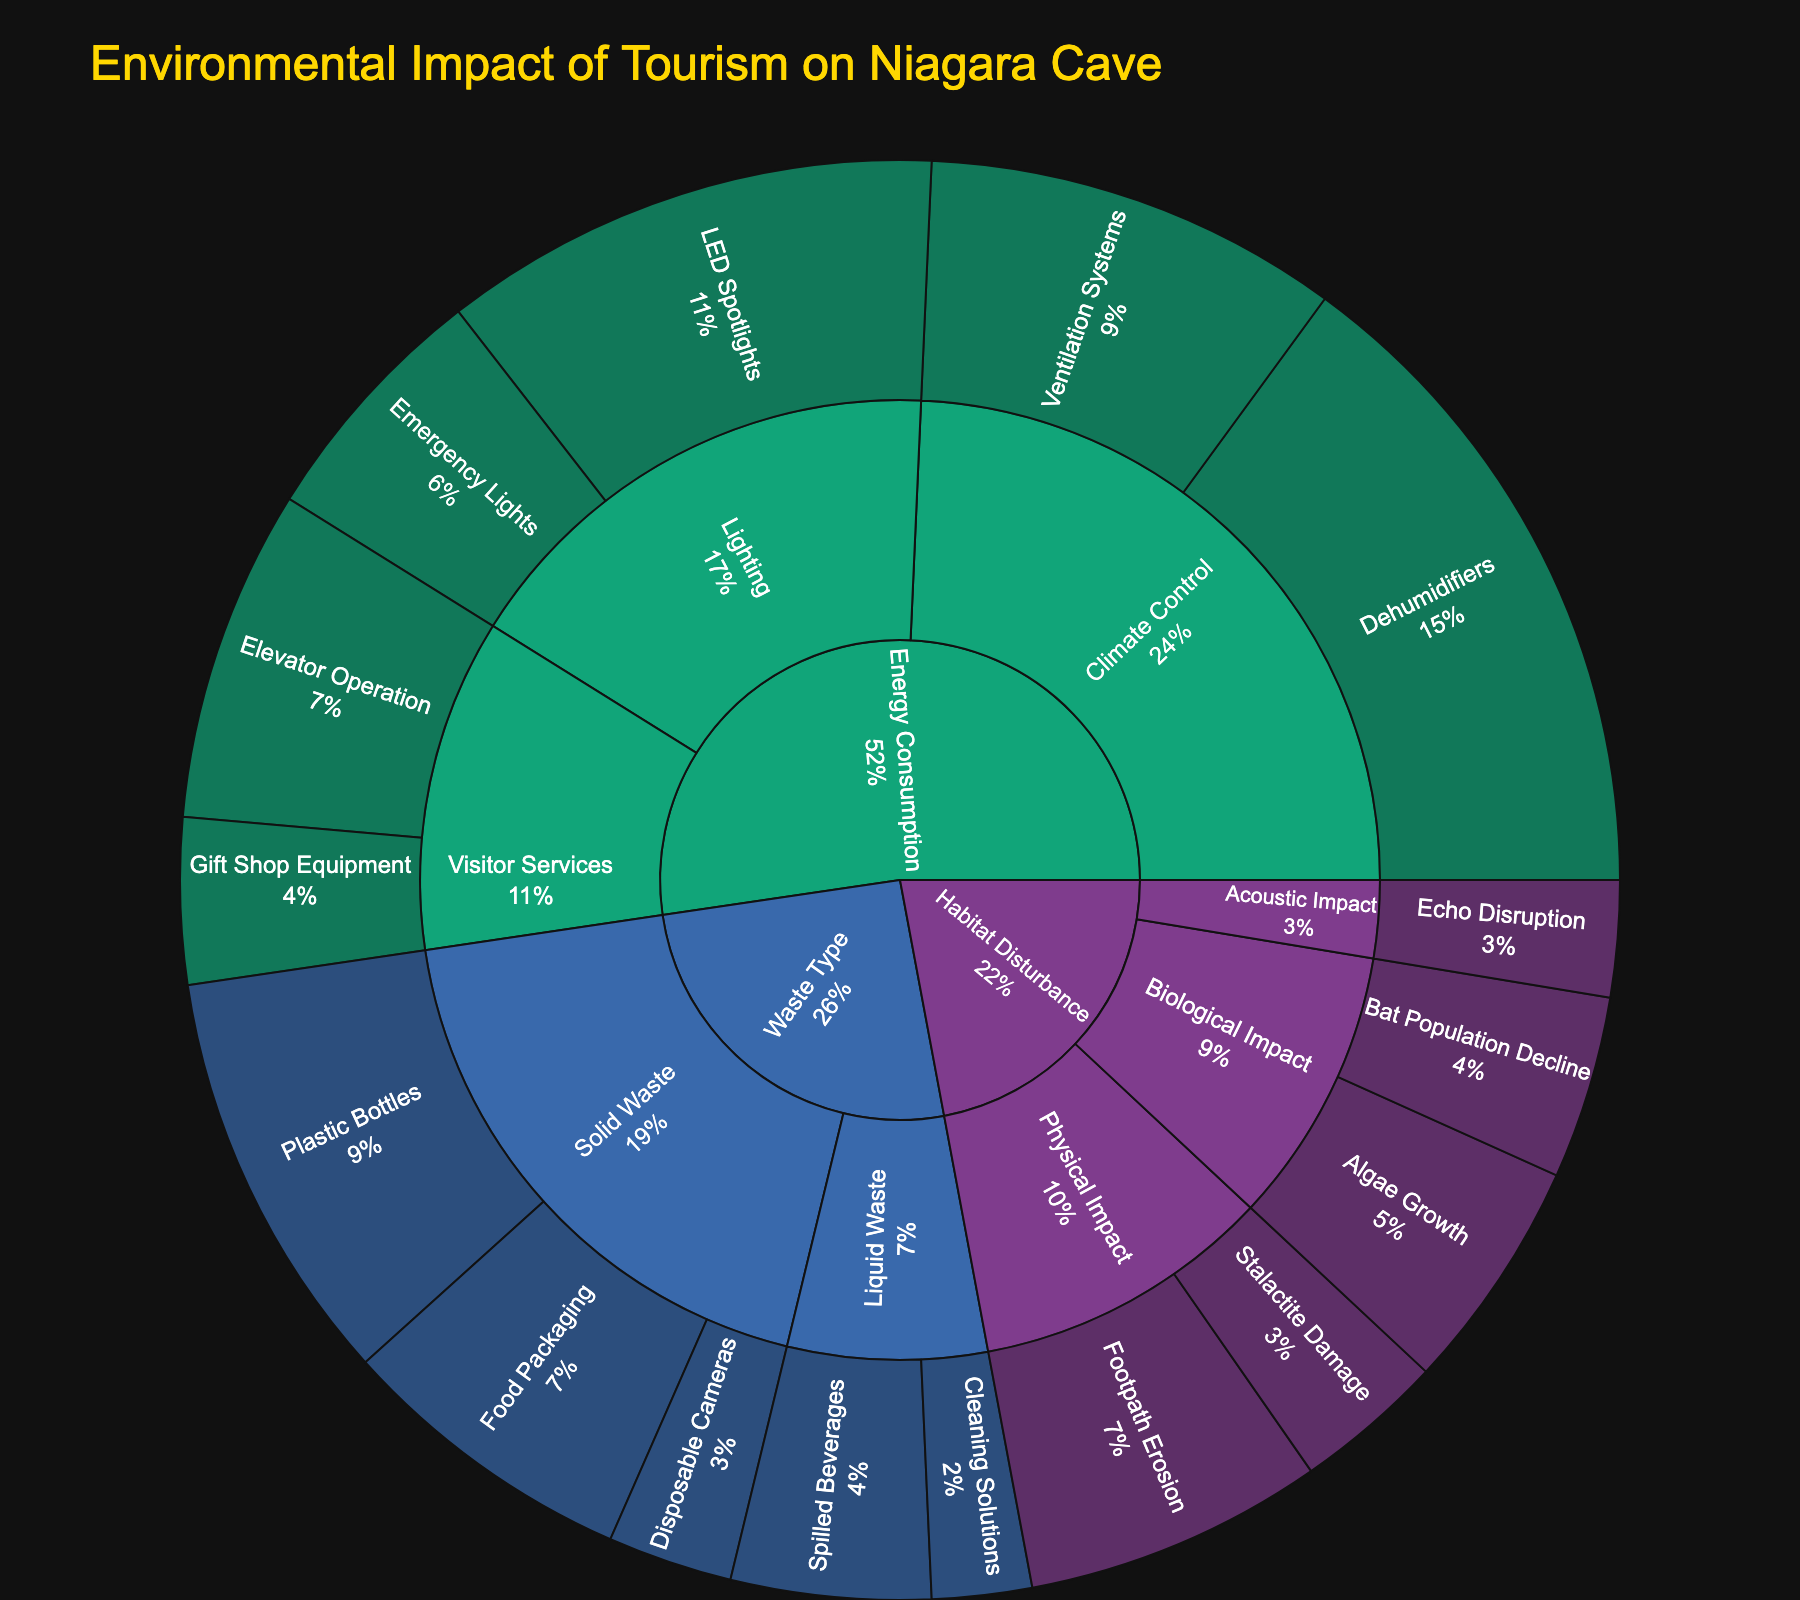What's the title of the figure? The title of the figure is located at the top center of the plot and provides a summary of what the plot represents.
Answer: Environmental Impact of Tourism on Niagara Cave Which waste type has a higher total impact, Solid or Liquid? Add the values of all items under Solid Waste and compare with the sum of values under Liquid Waste. Solid Waste: 250 + 180 + 75 = 505. Liquid Waste: 120 + 60 = 180. Hence, Solid Waste has a higher total impact.
Answer: Solid What is the percentage contribution of LED Spotlights to the Energy Consumption category? Look at the value for LED Spotlights (300) and sum the values of all items under Energy Consumption (300 + 150 + 400 + 250 + 200 + 100 = 1400). Then, calculate the percentage as (300/1400) * 100.
Answer: 21.4% Which item contributes more to Habitat Disturbance, Footpath Erosion or Algae Growth? Compare the values of Footpath Erosion (180) and Algae Growth (140).
Answer: Footpath Erosion What is the total value of all the items under the category 'Habitat Disturbance'? Add the values of all items under Habitat Disturbance: 180 + 90 + 140 + 110 + 70.
Answer: 590 Which category has the least overall impact? Compare the total values of Waste Type, Energy Consumption, and Habitat Disturbance. Waste Type: 505 + 180 = 685. Energy Consumption: 1400. Habitat Disturbance: 590. The category with the smallest sum is Habitat Disturbance.
Answer: Habitat Disturbance How does the impact of Emergency Lights compare to that of Elevator Operation? Compare the values of Emergency Lights (150) and Elevator Operation (200).
Answer: Elevator Operation has a higher impact Which subcategory under Waste Type has a higher impact, Solid Waste or Liquid Waste? Sum up the values under Solid Waste and Liquid Waste. Solid Waste: 250 + 180 + 75 = 505. Liquid Waste: 120 + 60 = 180. Solid Waste has a higher impact.
Answer: Solid Waste What is the combined value of Climate Control items? Add the values of Dehumidifiers (400) and Ventilation Systems (250).
Answer: 650 What percentage of the Habitat Disturbance category is due to Bat Population Decline? Find the value for Bat Population Decline (110) and the total value under Habitat Disturbance (590). Calculate as (110/590) * 100.
Answer: 18.6% 